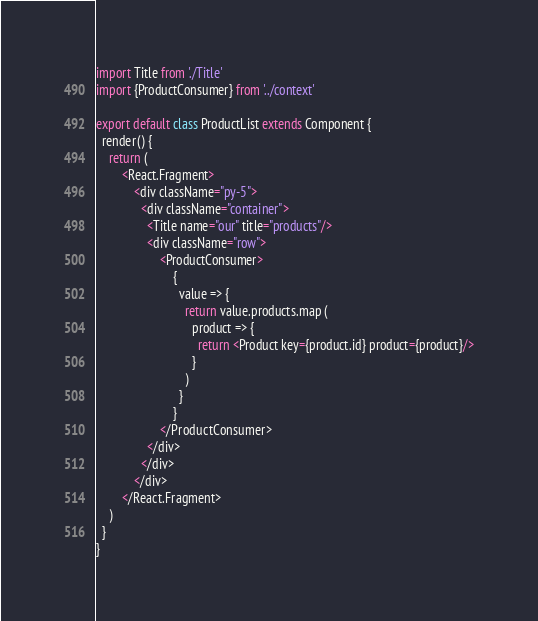<code> <loc_0><loc_0><loc_500><loc_500><_JavaScript_>import Title from './Title'
import {ProductConsumer} from '../context'

export default class ProductList extends Component {
  render() {
    return (
        <React.Fragment>
            <div className="py-5">
              <div className="container">
                <Title name="our" title="products"/>
                <div className="row">
                    <ProductConsumer>
                        {
                          value => {
                            return value.products.map (
                              product => {
                                return <Product key={product.id} product={product}/>
                              }
                            )
                          }
                        }
                    </ProductConsumer>
                </div>
              </div>
            </div>
        </React.Fragment>
    )
  }
}
</code> 